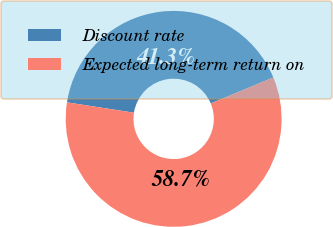Convert chart. <chart><loc_0><loc_0><loc_500><loc_500><pie_chart><fcel>Discount rate<fcel>Expected long-term return on<nl><fcel>41.28%<fcel>58.72%<nl></chart> 